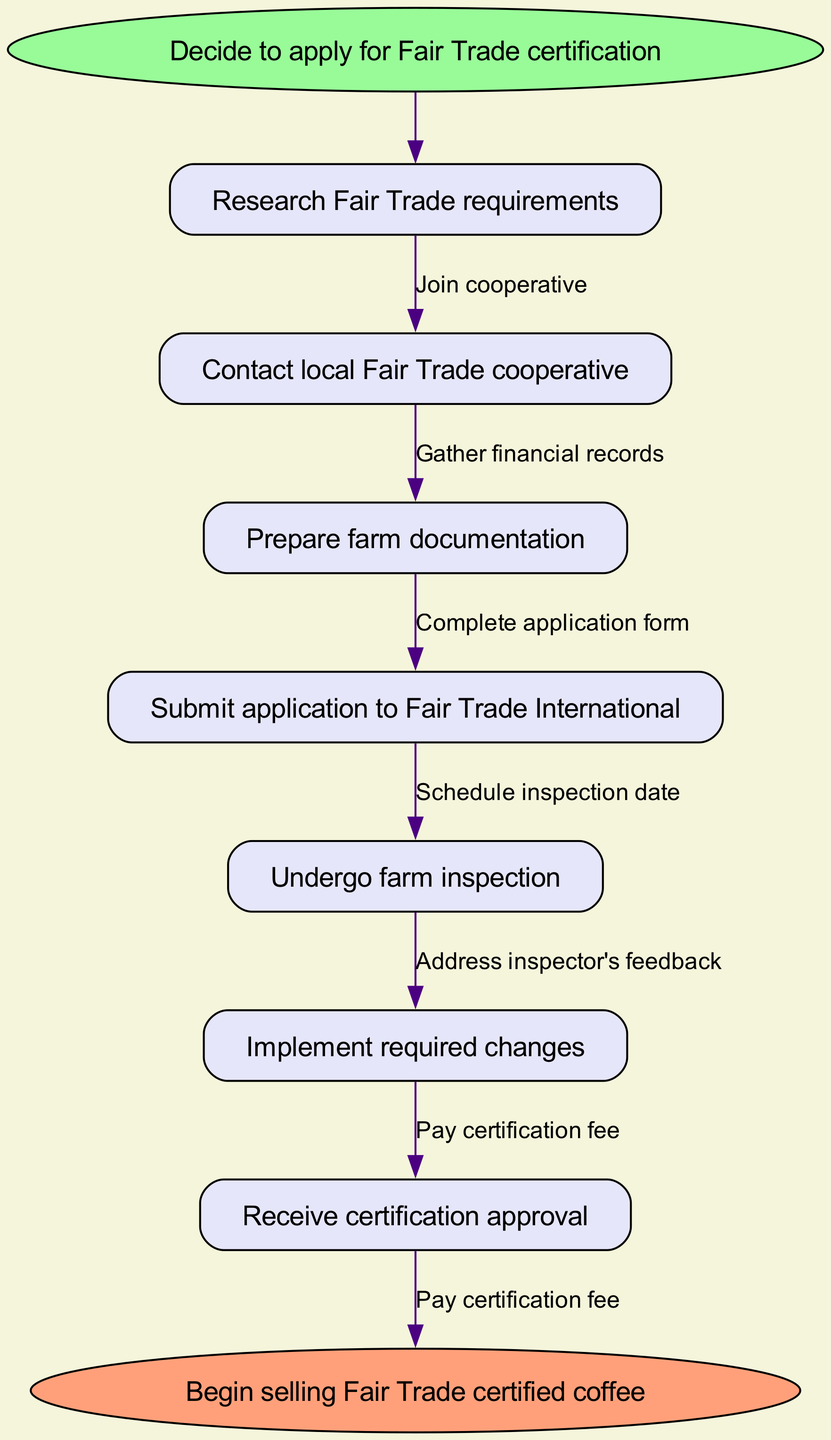What is the start point of the process? The first node in the flow chart denotes the starting point, which is "Decide to apply for Fair Trade certification".
Answer: Decide to apply for Fair Trade certification How many nodes are there in the flow chart? By counting each distinct step in the nodes section of the diagram, we find there are 7 steps (nodes).
Answer: 7 What is the last step before receiving certification approval? The flow chart indicates that the last step before certification approval is "Implement required changes".
Answer: Implement required changes What is the label of the edge between "Submit application to Fair Trade International" and "Undergo farm inspection"? The label of the edge connecting these two nodes is the action taken to facilitate that movement, which is "Schedule inspection date".
Answer: Schedule inspection date What must a farmer do after deciding to apply for certification? The first action a farmer must take after deciding to apply is to "Research Fair Trade requirements", as depicted directly following the start node.
Answer: Research Fair Trade requirements Which node comes before “Begin selling Fair Trade certified coffee”? The node immediately preceding the end node "Begin selling Fair Trade certified coffee" is "Receive certification approval", making it the last step before beginning to sell.
Answer: Receive certification approval How many edges are there in total? The flow chart indicates actions as relationships between nodes. Given there are 7 nodes and that edges connect them linearly with an edge labeled "Pay certification fee", we can count 6 edges total.
Answer: 6 What is the function of the node labeled “Contact local Fair Trade cooperative”? The purpose of this action in the sequence is to promote the initiation of the application process by seeking support or guidance from local Fair Trade groups, which is crucial to understanding requirements.
Answer: Support or guidance What action needs to be taken after gathering financial records? After gathering financial records, the farmer needs to "Complete application form" as the subsequent action in the flow of the certification process.
Answer: Complete application form 